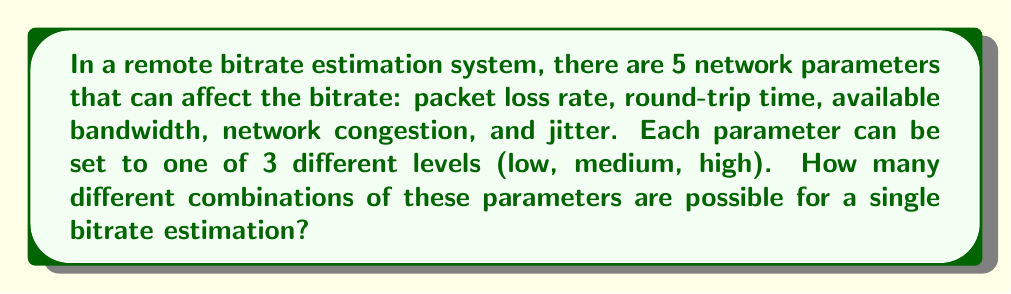Provide a solution to this math problem. To solve this problem, we need to use the multiplication principle of counting. Here's a step-by-step explanation:

1. We have 5 different parameters:
   - Packet loss rate
   - Round-trip time
   - Available bandwidth
   - Network congestion
   - Jitter

2. Each parameter can be set to one of 3 levels:
   - Low
   - Medium
   - High

3. For each parameter, we have 3 choices, and we need to make this choice for all 5 parameters.

4. According to the multiplication principle, when we have a series of independent choices, we multiply the number of options for each choice to get the total number of possible combinations.

5. In this case, we have:
   $$ 3 \times 3 \times 3 \times 3 \times 3 $$

6. This can be written as:
   $$ 3^5 $$

7. Calculating this:
   $$ 3^5 = 3 \times 3 \times 3 \times 3 \times 3 = 243 $$

Therefore, there are 243 possible combinations of these network parameters for a single bitrate estimation.
Answer: The number of possible combinations is $3^5 = 243$. 